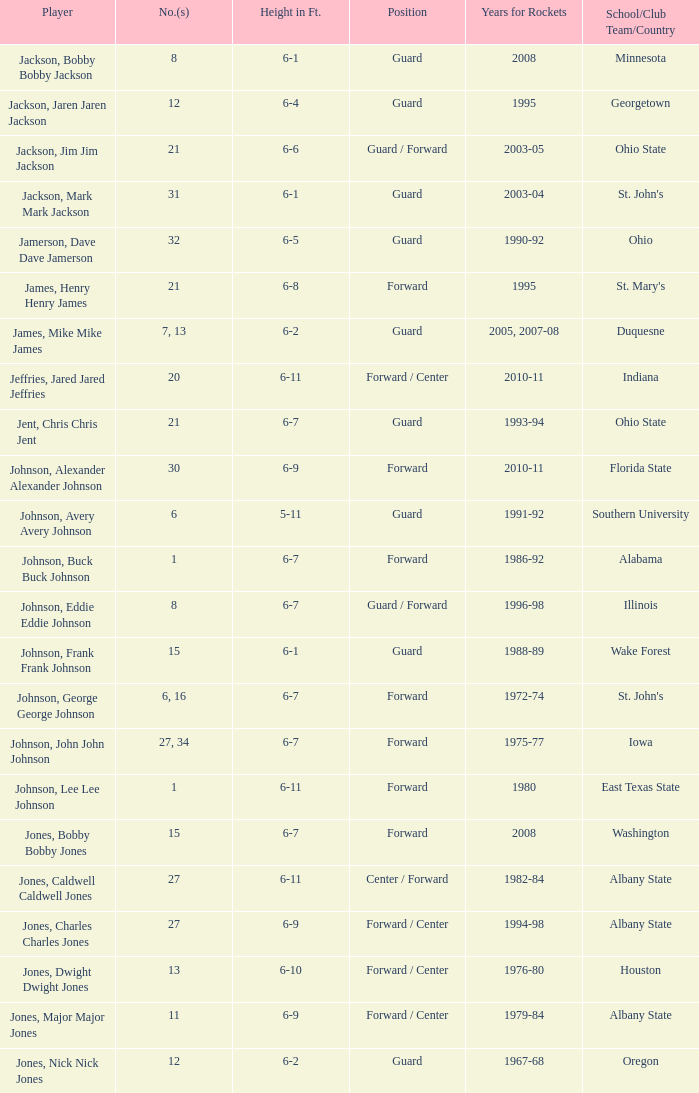What is the total of the participant who visited southern university? 6.0. 